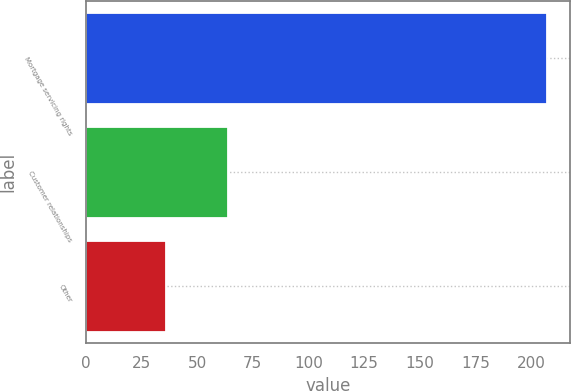<chart> <loc_0><loc_0><loc_500><loc_500><bar_chart><fcel>Mortgage servicing rights<fcel>Customer relationships<fcel>Other<nl><fcel>207<fcel>64<fcel>36<nl></chart> 